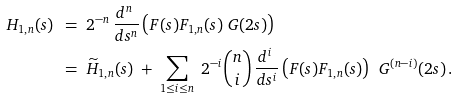<formula> <loc_0><loc_0><loc_500><loc_500>H _ { 1 , n } ( s ) \ & = \ 2 ^ { - n } \, \frac { d ^ { n } \ } { d s ^ { n } } \left ( F ( s ) F _ { 1 , n } ( s ) \ G ( 2 s ) \right ) \\ & = \ \widetilde { H } _ { 1 , n } ( s ) \ + \ \sum _ { 1 \leq i \leq n } \ 2 ^ { - i } \binom { n } { i } \, \frac { d ^ { i } \ } { d s ^ { i } } \left ( F ( s ) F _ { 1 , n } ( s ) \right ) \, \ G ^ { ( n - i ) } ( 2 s ) \, .</formula> 